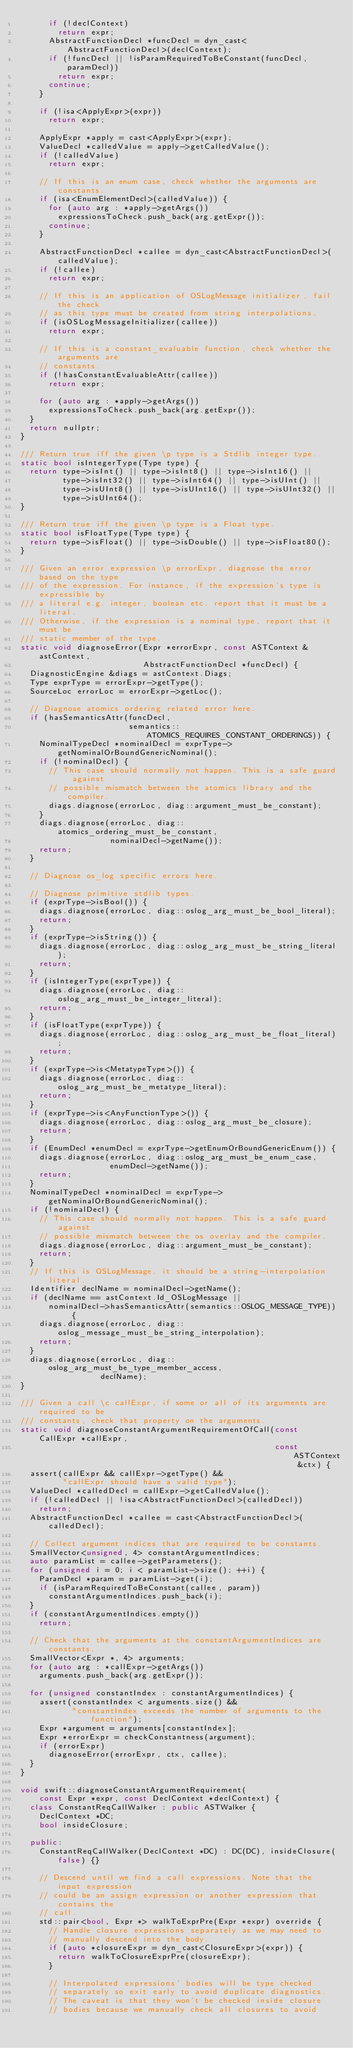Convert code to text. <code><loc_0><loc_0><loc_500><loc_500><_C++_>      if (!declContext)
        return expr;
      AbstractFunctionDecl *funcDecl = dyn_cast<AbstractFunctionDecl>(declContext);
      if (!funcDecl || !isParamRequiredToBeConstant(funcDecl, paramDecl))
        return expr;
      continue;
    }

    if (!isa<ApplyExpr>(expr))
      return expr;

    ApplyExpr *apply = cast<ApplyExpr>(expr);
    ValueDecl *calledValue = apply->getCalledValue();
    if (!calledValue)
      return expr;

    // If this is an enum case, check whether the arguments are constants.
    if (isa<EnumElementDecl>(calledValue)) {
      for (auto arg : *apply->getArgs())
        expressionsToCheck.push_back(arg.getExpr());
      continue;
    }

    AbstractFunctionDecl *callee = dyn_cast<AbstractFunctionDecl>(calledValue);
    if (!callee)
      return expr;

    // If this is an application of OSLogMessage initializer, fail the check
    // as this type must be created from string interpolations.
    if (isOSLogMessageInitializer(callee))
      return expr;

    // If this is a constant_evaluable function, check whether the arguments are
    // constants.
    if (!hasConstantEvaluableAttr(callee))
      return expr;

    for (auto arg : *apply->getArgs())
      expressionsToCheck.push_back(arg.getExpr());
  }
  return nullptr;
}

/// Return true iff the given \p type is a Stdlib integer type.
static bool isIntegerType(Type type) {
  return type->isInt() || type->isInt8() || type->isInt16() ||
         type->isInt32() || type->isInt64() || type->isUInt() ||
         type->isUInt8() || type->isUInt16() || type->isUInt32() ||
         type->isUInt64();
}

/// Return true iff the given \p type is a Float type.
static bool isFloatType(Type type) {
  return type->isFloat() || type->isDouble() || type->isFloat80();
}

/// Given an error expression \p errorExpr, diagnose the error based on the type
/// of the expression. For instance, if the expression's type is expressible by
/// a literal e.g. integer, boolean etc. report that it must be a literal.
/// Otherwise, if the expression is a nominal type, report that it must be
/// static member of the type.
static void diagnoseError(Expr *errorExpr, const ASTContext &astContext,
                          AbstractFunctionDecl *funcDecl) {
  DiagnosticEngine &diags = astContext.Diags;
  Type exprType = errorExpr->getType();
  SourceLoc errorLoc = errorExpr->getLoc();

  // Diagnose atomics ordering related error here.
  if (hasSemanticsAttr(funcDecl,
                       semantics::ATOMICS_REQUIRES_CONSTANT_ORDERINGS)) {
    NominalTypeDecl *nominalDecl = exprType->getNominalOrBoundGenericNominal();
    if (!nominalDecl) {
      // This case should normally not happen. This is a safe guard against
      // possible mismatch between the atomics library and the compiler.
      diags.diagnose(errorLoc, diag::argument_must_be_constant);
    }
    diags.diagnose(errorLoc, diag::atomics_ordering_must_be_constant,
                   nominalDecl->getName());
    return;
  }

  // Diagnose os_log specific errors here.

  // Diagnose primitive stdlib types.
  if (exprType->isBool()) {
    diags.diagnose(errorLoc, diag::oslog_arg_must_be_bool_literal);
    return;
  }
  if (exprType->isString()) {
    diags.diagnose(errorLoc, diag::oslog_arg_must_be_string_literal);
    return;
  }
  if (isIntegerType(exprType)) {
    diags.diagnose(errorLoc, diag::oslog_arg_must_be_integer_literal);
    return;
  }
  if (isFloatType(exprType)) {
    diags.diagnose(errorLoc, diag::oslog_arg_must_be_float_literal);
    return;
  }
  if (exprType->is<MetatypeType>()) {
    diags.diagnose(errorLoc, diag::oslog_arg_must_be_metatype_literal);
    return;
  }
  if (exprType->is<AnyFunctionType>()) {
    diags.diagnose(errorLoc, diag::oslog_arg_must_be_closure);
    return;
  }
  if (EnumDecl *enumDecl = exprType->getEnumOrBoundGenericEnum()) {
    diags.diagnose(errorLoc, diag::oslog_arg_must_be_enum_case,
                   enumDecl->getName());
    return;
  }
  NominalTypeDecl *nominalDecl = exprType->getNominalOrBoundGenericNominal();
  if (!nominalDecl) {
    // This case should normally not happen. This is a safe guard against
    // possible mismatch between the os overlay and the compiler.
    diags.diagnose(errorLoc, diag::argument_must_be_constant);
    return;
  }
  // If this is OSLogMessage, it should be a string-interpolation literal.
  Identifier declName = nominalDecl->getName();
  if (declName == astContext.Id_OSLogMessage ||
      nominalDecl->hasSemanticsAttr(semantics::OSLOG_MESSAGE_TYPE)) {
    diags.diagnose(errorLoc, diag::oslog_message_must_be_string_interpolation);
    return;
  }
  diags.diagnose(errorLoc, diag::oslog_arg_must_be_type_member_access,
                 declName);
}

/// Given a call \c callExpr, if some or all of its arguments are required to be
/// constants, check that property on the arguments.
static void diagnoseConstantArgumentRequirementOfCall(const CallExpr *callExpr,
                                                      const ASTContext &ctx) {
  assert(callExpr && callExpr->getType() &&
         "callExpr should have a valid type");
  ValueDecl *calledDecl = callExpr->getCalledValue();
  if (!calledDecl || !isa<AbstractFunctionDecl>(calledDecl))
    return;
  AbstractFunctionDecl *callee = cast<AbstractFunctionDecl>(calledDecl);

  // Collect argument indices that are required to be constants.
  SmallVector<unsigned, 4> constantArgumentIndices;
  auto paramList = callee->getParameters();
  for (unsigned i = 0; i < paramList->size(); ++i) {
    ParamDecl *param = paramList->get(i);
    if (isParamRequiredToBeConstant(callee, param))
      constantArgumentIndices.push_back(i);
  }
  if (constantArgumentIndices.empty())
    return;

  // Check that the arguments at the constantArgumentIndices are constants.
  SmallVector<Expr *, 4> arguments;
  for (auto arg : *callExpr->getArgs())
    arguments.push_back(arg.getExpr());

  for (unsigned constantIndex : constantArgumentIndices) {
    assert(constantIndex < arguments.size() &&
           "constantIndex exceeds the number of arguments to the function");
    Expr *argument = arguments[constantIndex];
    Expr *errorExpr = checkConstantness(argument);
    if (errorExpr)
      diagnoseError(errorExpr, ctx, callee);
  }
}

void swift::diagnoseConstantArgumentRequirement(
    const Expr *expr, const DeclContext *declContext) {
  class ConstantReqCallWalker : public ASTWalker {
    DeclContext *DC;
    bool insideClosure;

  public:
    ConstantReqCallWalker(DeclContext *DC) : DC(DC), insideClosure(false) {}

    // Descend until we find a call expressions. Note that the input expression
    // could be an assign expression or another expression that contains the
    // call.
    std::pair<bool, Expr *> walkToExprPre(Expr *expr) override {
      // Handle closure expressions separately as we may need to
      // manually descend into the body.
      if (auto *closureExpr = dyn_cast<ClosureExpr>(expr)) {
        return walkToClosureExprPre(closureExpr);
      }

      // Interpolated expressions' bodies will be type checked
      // separately so exit early to avoid duplicate diagnostics.
      // The caveat is that they won't be checked inside closure
      // bodies because we manually check all closures to avoid</code> 